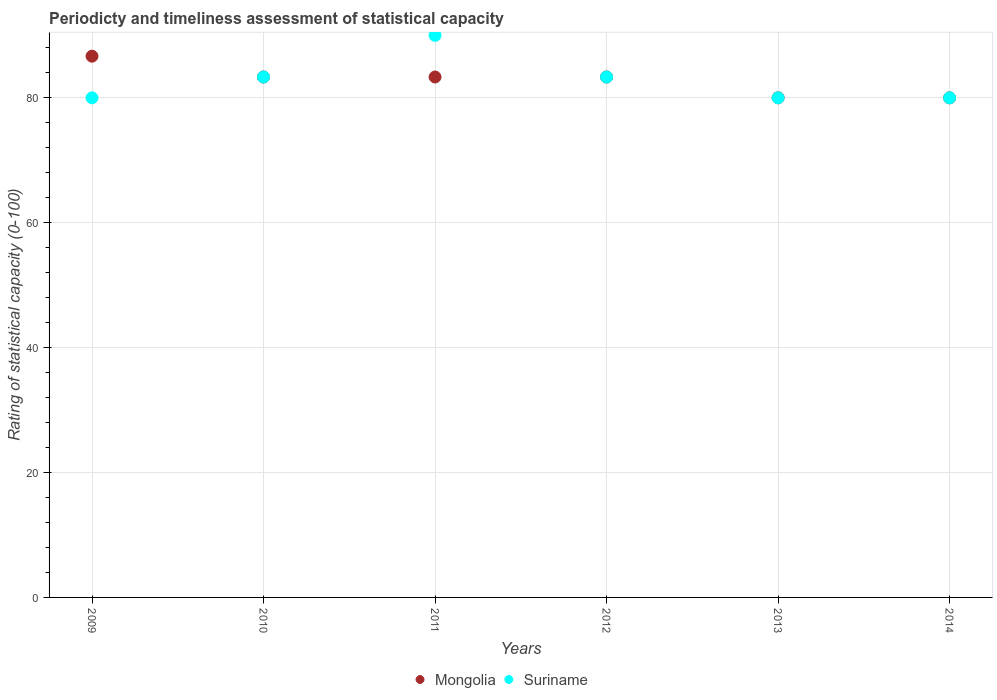How many different coloured dotlines are there?
Provide a succinct answer. 2. Is the number of dotlines equal to the number of legend labels?
Keep it short and to the point. Yes. In which year was the rating of statistical capacity in Mongolia maximum?
Make the answer very short. 2009. What is the total rating of statistical capacity in Suriname in the graph?
Make the answer very short. 496.67. What is the difference between the rating of statistical capacity in Suriname in 2010 and that in 2013?
Keep it short and to the point. 3.33. What is the difference between the rating of statistical capacity in Mongolia in 2010 and the rating of statistical capacity in Suriname in 2012?
Your answer should be very brief. 0. What is the average rating of statistical capacity in Suriname per year?
Offer a very short reply. 82.78. In the year 2011, what is the difference between the rating of statistical capacity in Suriname and rating of statistical capacity in Mongolia?
Your response must be concise. 6.67. What is the ratio of the rating of statistical capacity in Mongolia in 2011 to that in 2012?
Your response must be concise. 1. Is the rating of statistical capacity in Mongolia in 2010 less than that in 2013?
Give a very brief answer. No. Is the difference between the rating of statistical capacity in Suriname in 2010 and 2012 greater than the difference between the rating of statistical capacity in Mongolia in 2010 and 2012?
Ensure brevity in your answer.  No. What is the difference between the highest and the second highest rating of statistical capacity in Suriname?
Offer a very short reply. 6.67. What is the difference between the highest and the lowest rating of statistical capacity in Mongolia?
Make the answer very short. 6.67. Is the sum of the rating of statistical capacity in Mongolia in 2010 and 2012 greater than the maximum rating of statistical capacity in Suriname across all years?
Offer a terse response. Yes. Does the rating of statistical capacity in Suriname monotonically increase over the years?
Make the answer very short. No. Is the rating of statistical capacity in Suriname strictly greater than the rating of statistical capacity in Mongolia over the years?
Ensure brevity in your answer.  No. How many dotlines are there?
Your response must be concise. 2. How many years are there in the graph?
Provide a succinct answer. 6. Does the graph contain any zero values?
Make the answer very short. No. Where does the legend appear in the graph?
Ensure brevity in your answer.  Bottom center. How many legend labels are there?
Ensure brevity in your answer.  2. What is the title of the graph?
Your answer should be compact. Periodicty and timeliness assessment of statistical capacity. What is the label or title of the Y-axis?
Ensure brevity in your answer.  Rating of statistical capacity (0-100). What is the Rating of statistical capacity (0-100) of Mongolia in 2009?
Provide a succinct answer. 86.67. What is the Rating of statistical capacity (0-100) in Mongolia in 2010?
Keep it short and to the point. 83.33. What is the Rating of statistical capacity (0-100) in Suriname in 2010?
Provide a short and direct response. 83.33. What is the Rating of statistical capacity (0-100) in Mongolia in 2011?
Provide a succinct answer. 83.33. What is the Rating of statistical capacity (0-100) in Suriname in 2011?
Make the answer very short. 90. What is the Rating of statistical capacity (0-100) of Mongolia in 2012?
Your response must be concise. 83.33. What is the Rating of statistical capacity (0-100) in Suriname in 2012?
Give a very brief answer. 83.33. What is the Rating of statistical capacity (0-100) of Suriname in 2013?
Provide a short and direct response. 80. What is the Rating of statistical capacity (0-100) in Suriname in 2014?
Ensure brevity in your answer.  80. Across all years, what is the maximum Rating of statistical capacity (0-100) of Mongolia?
Your answer should be compact. 86.67. Across all years, what is the maximum Rating of statistical capacity (0-100) in Suriname?
Make the answer very short. 90. Across all years, what is the minimum Rating of statistical capacity (0-100) in Suriname?
Offer a terse response. 80. What is the total Rating of statistical capacity (0-100) of Mongolia in the graph?
Your answer should be very brief. 496.67. What is the total Rating of statistical capacity (0-100) of Suriname in the graph?
Provide a succinct answer. 496.67. What is the difference between the Rating of statistical capacity (0-100) in Mongolia in 2009 and that in 2010?
Provide a succinct answer. 3.33. What is the difference between the Rating of statistical capacity (0-100) of Suriname in 2009 and that in 2010?
Your answer should be compact. -3.33. What is the difference between the Rating of statistical capacity (0-100) of Mongolia in 2009 and that in 2013?
Ensure brevity in your answer.  6.67. What is the difference between the Rating of statistical capacity (0-100) of Suriname in 2010 and that in 2011?
Your answer should be compact. -6.67. What is the difference between the Rating of statistical capacity (0-100) in Mongolia in 2010 and that in 2012?
Your answer should be very brief. 0. What is the difference between the Rating of statistical capacity (0-100) of Mongolia in 2010 and that in 2013?
Your answer should be compact. 3.33. What is the difference between the Rating of statistical capacity (0-100) in Suriname in 2010 and that in 2013?
Give a very brief answer. 3.33. What is the difference between the Rating of statistical capacity (0-100) of Suriname in 2011 and that in 2012?
Provide a succinct answer. 6.67. What is the difference between the Rating of statistical capacity (0-100) in Suriname in 2011 and that in 2014?
Make the answer very short. 10. What is the difference between the Rating of statistical capacity (0-100) of Mongolia in 2012 and that in 2013?
Offer a very short reply. 3.33. What is the difference between the Rating of statistical capacity (0-100) of Suriname in 2012 and that in 2013?
Provide a succinct answer. 3.33. What is the difference between the Rating of statistical capacity (0-100) of Mongolia in 2013 and that in 2014?
Make the answer very short. 0. What is the difference between the Rating of statistical capacity (0-100) of Suriname in 2013 and that in 2014?
Offer a very short reply. 0. What is the difference between the Rating of statistical capacity (0-100) of Mongolia in 2009 and the Rating of statistical capacity (0-100) of Suriname in 2011?
Offer a very short reply. -3.33. What is the difference between the Rating of statistical capacity (0-100) of Mongolia in 2009 and the Rating of statistical capacity (0-100) of Suriname in 2012?
Your response must be concise. 3.33. What is the difference between the Rating of statistical capacity (0-100) in Mongolia in 2010 and the Rating of statistical capacity (0-100) in Suriname in 2011?
Keep it short and to the point. -6.67. What is the difference between the Rating of statistical capacity (0-100) of Mongolia in 2010 and the Rating of statistical capacity (0-100) of Suriname in 2012?
Make the answer very short. 0. What is the difference between the Rating of statistical capacity (0-100) of Mongolia in 2011 and the Rating of statistical capacity (0-100) of Suriname in 2013?
Provide a succinct answer. 3.33. What is the difference between the Rating of statistical capacity (0-100) in Mongolia in 2012 and the Rating of statistical capacity (0-100) in Suriname in 2014?
Your response must be concise. 3.33. What is the average Rating of statistical capacity (0-100) of Mongolia per year?
Your answer should be very brief. 82.78. What is the average Rating of statistical capacity (0-100) in Suriname per year?
Offer a terse response. 82.78. In the year 2010, what is the difference between the Rating of statistical capacity (0-100) in Mongolia and Rating of statistical capacity (0-100) in Suriname?
Provide a short and direct response. 0. In the year 2011, what is the difference between the Rating of statistical capacity (0-100) in Mongolia and Rating of statistical capacity (0-100) in Suriname?
Offer a very short reply. -6.67. In the year 2014, what is the difference between the Rating of statistical capacity (0-100) of Mongolia and Rating of statistical capacity (0-100) of Suriname?
Offer a terse response. 0. What is the ratio of the Rating of statistical capacity (0-100) in Mongolia in 2009 to that in 2011?
Ensure brevity in your answer.  1.04. What is the ratio of the Rating of statistical capacity (0-100) in Mongolia in 2009 to that in 2012?
Keep it short and to the point. 1.04. What is the ratio of the Rating of statistical capacity (0-100) in Suriname in 2009 to that in 2012?
Provide a short and direct response. 0.96. What is the ratio of the Rating of statistical capacity (0-100) of Suriname in 2009 to that in 2013?
Provide a short and direct response. 1. What is the ratio of the Rating of statistical capacity (0-100) in Mongolia in 2010 to that in 2011?
Your answer should be very brief. 1. What is the ratio of the Rating of statistical capacity (0-100) in Suriname in 2010 to that in 2011?
Offer a terse response. 0.93. What is the ratio of the Rating of statistical capacity (0-100) of Mongolia in 2010 to that in 2012?
Offer a very short reply. 1. What is the ratio of the Rating of statistical capacity (0-100) of Mongolia in 2010 to that in 2013?
Provide a succinct answer. 1.04. What is the ratio of the Rating of statistical capacity (0-100) in Suriname in 2010 to that in 2013?
Make the answer very short. 1.04. What is the ratio of the Rating of statistical capacity (0-100) in Mongolia in 2010 to that in 2014?
Your answer should be compact. 1.04. What is the ratio of the Rating of statistical capacity (0-100) of Suriname in 2010 to that in 2014?
Ensure brevity in your answer.  1.04. What is the ratio of the Rating of statistical capacity (0-100) of Suriname in 2011 to that in 2012?
Your answer should be compact. 1.08. What is the ratio of the Rating of statistical capacity (0-100) of Mongolia in 2011 to that in 2013?
Keep it short and to the point. 1.04. What is the ratio of the Rating of statistical capacity (0-100) of Mongolia in 2011 to that in 2014?
Offer a very short reply. 1.04. What is the ratio of the Rating of statistical capacity (0-100) in Mongolia in 2012 to that in 2013?
Offer a very short reply. 1.04. What is the ratio of the Rating of statistical capacity (0-100) in Suriname in 2012 to that in 2013?
Make the answer very short. 1.04. What is the ratio of the Rating of statistical capacity (0-100) of Mongolia in 2012 to that in 2014?
Your response must be concise. 1.04. What is the ratio of the Rating of statistical capacity (0-100) of Suriname in 2012 to that in 2014?
Keep it short and to the point. 1.04. What is the ratio of the Rating of statistical capacity (0-100) in Suriname in 2013 to that in 2014?
Keep it short and to the point. 1. What is the difference between the highest and the second highest Rating of statistical capacity (0-100) of Mongolia?
Ensure brevity in your answer.  3.33. What is the difference between the highest and the second highest Rating of statistical capacity (0-100) of Suriname?
Offer a very short reply. 6.67. 